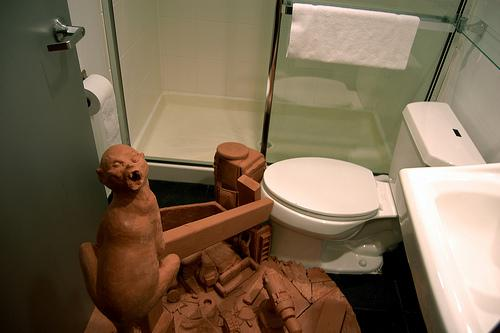Question: what is next to the toilet?
Choices:
A. A plunger.
B. A sink.
C. Toilet paper.
D. Garbage can.
Answer with the letter. Answer: B Question: what color is the figurine?
Choices:
A. Blue.
B. Green.
C. Black.
D. Clay or terracotta.
Answer with the letter. Answer: D Question: how do you flush the toilet?
Choices:
A. Pull the string.
B. Push the flush button on the tank.
C. Use your foot.
D. It's automatic.
Answer with the letter. Answer: B Question: when do you close the lid?
Choices:
A. If you are finished.
B. Before leaving.
C. After you eat.
D. When you go home.
Answer with the letter. Answer: A Question: why is the towel on the rack?
Choices:
A. To allow it to dry.
B. It is dirty.
C. It is clean.
D. Needs to be changed.
Answer with the letter. Answer: A 